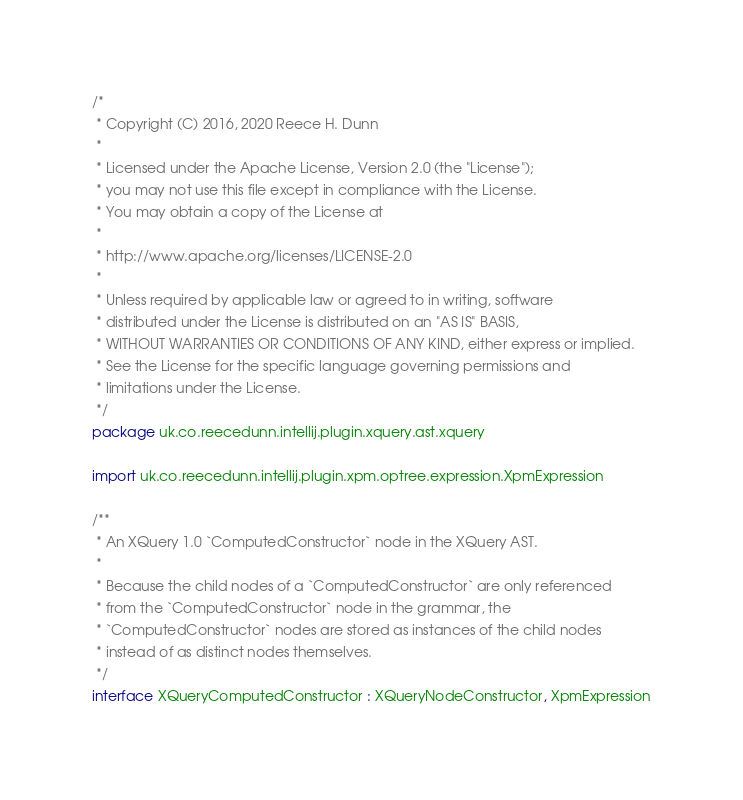<code> <loc_0><loc_0><loc_500><loc_500><_Kotlin_>/*
 * Copyright (C) 2016, 2020 Reece H. Dunn
 *
 * Licensed under the Apache License, Version 2.0 (the "License");
 * you may not use this file except in compliance with the License.
 * You may obtain a copy of the License at
 *
 * http://www.apache.org/licenses/LICENSE-2.0
 *
 * Unless required by applicable law or agreed to in writing, software
 * distributed under the License is distributed on an "AS IS" BASIS,
 * WITHOUT WARRANTIES OR CONDITIONS OF ANY KIND, either express or implied.
 * See the License for the specific language governing permissions and
 * limitations under the License.
 */
package uk.co.reecedunn.intellij.plugin.xquery.ast.xquery

import uk.co.reecedunn.intellij.plugin.xpm.optree.expression.XpmExpression

/**
 * An XQuery 1.0 `ComputedConstructor` node in the XQuery AST.
 *
 * Because the child nodes of a `ComputedConstructor` are only referenced
 * from the `ComputedConstructor` node in the grammar, the
 * `ComputedConstructor` nodes are stored as instances of the child nodes
 * instead of as distinct nodes themselves.
 */
interface XQueryComputedConstructor : XQueryNodeConstructor, XpmExpression
</code> 